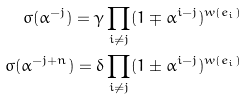Convert formula to latex. <formula><loc_0><loc_0><loc_500><loc_500>\sigma ( \alpha ^ { - j } ) = \gamma \prod _ { i \ne j } ( 1 \mp \alpha ^ { i - j } ) ^ { w ( e _ { i } ) } \\ \sigma ( \alpha ^ { - j + n } ) = \delta \prod _ { i \ne j } ( 1 \pm \alpha ^ { i - j } ) ^ { w ( e _ { i } ) }</formula> 